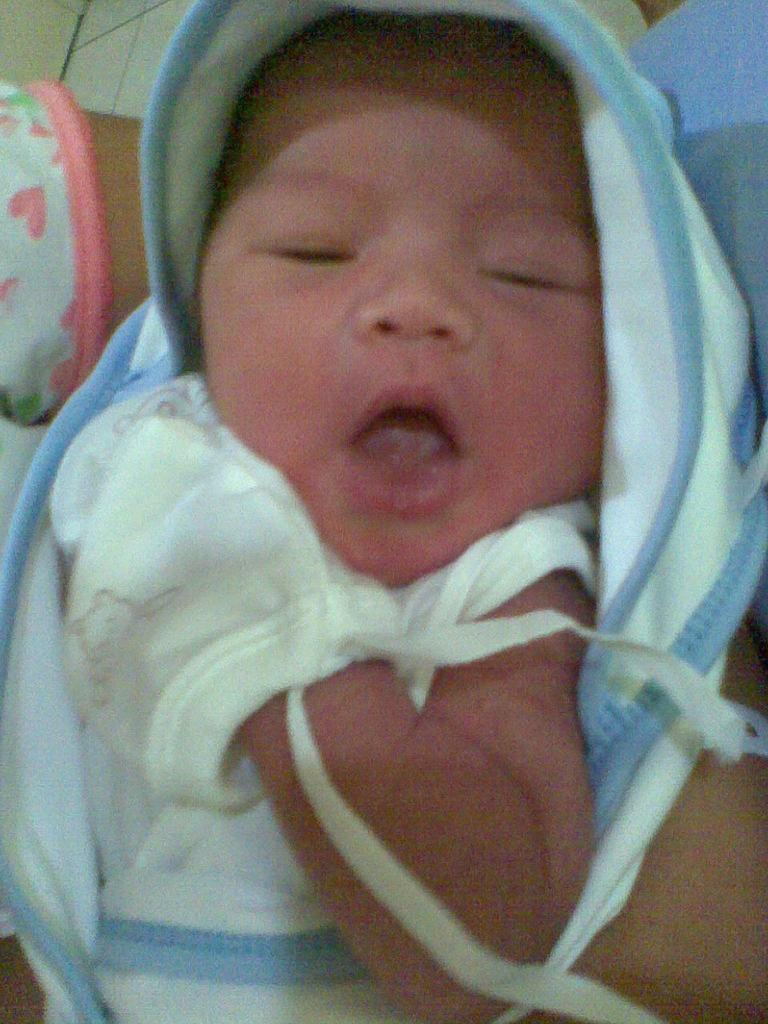What is the person in the image doing? The person is holding a baby in the image. What can be seen beneath the person and baby? The floor is visible in the image. What type of curve can be seen in the baby's taste for rice in the image? There is no information about the baby's taste for rice or any curves related to it in the image. 